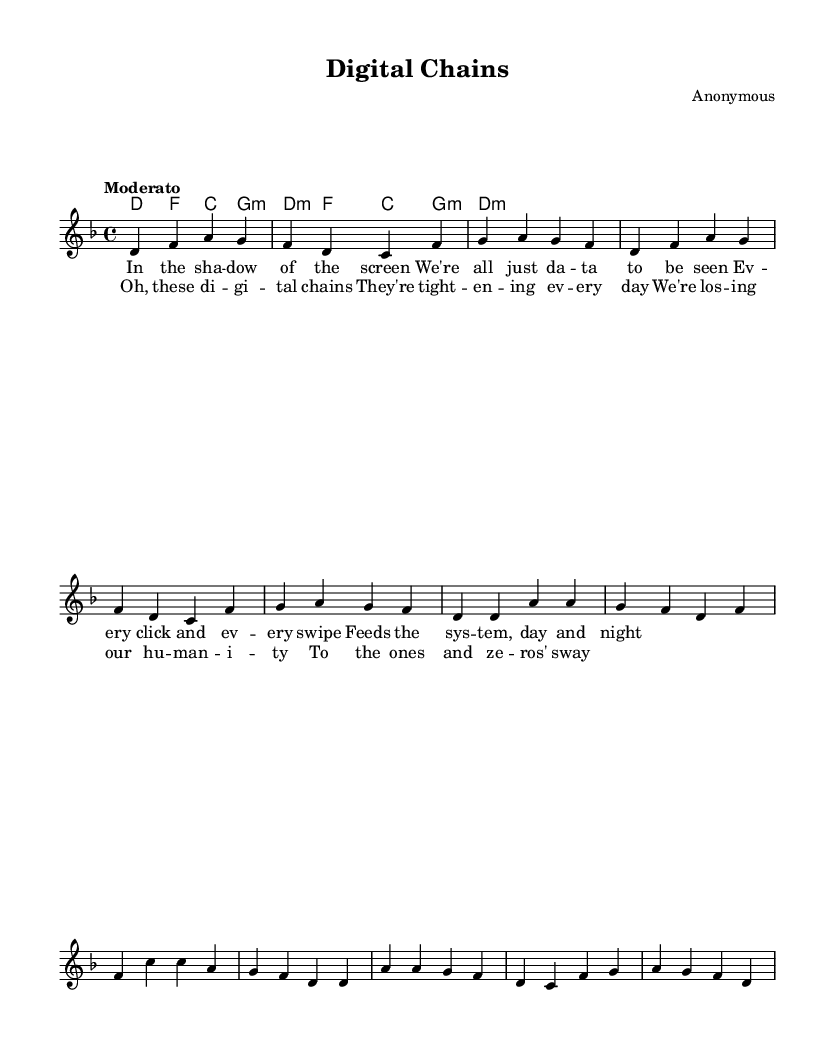What is the key signature of this music? The key signature is D minor, indicated by one flat (B flat) in the key signature.
Answer: D minor What is the time signature of this piece? The time signature is 4/4, which is shown at the beginning of the score, indicating four beats per measure.
Answer: 4/4 What is the tempo marking? The tempo marking is "Moderato," suggesting a moderate pace for the piece, typically around 108-120 beats per minute.
Answer: Moderato How many bars are in the chorus section? The chorus consists of 4 bars, as can be identified through the grouping of the note sequences and the structure of the lyrics underneath.
Answer: 4 What is the primary chord used throughout the verse? The primary chord in the verse is D minor, as evidenced by the repeated appearance of the D minor chord in the harmonic structure.
Answer: D minor What lyrical theme is reflected in the chorus? The chorus reflects the theme of digital oppression and loss of humanity, focusing on the metaphor of "digital chains."
Answer: Digital oppression What type of musical instrument is likely used for this piece in performance? Given the chord arrangement and melody structure, it is likely that a piano or guitar is used, as these instruments commonly perform folk protest songs.
Answer: Piano or guitar 